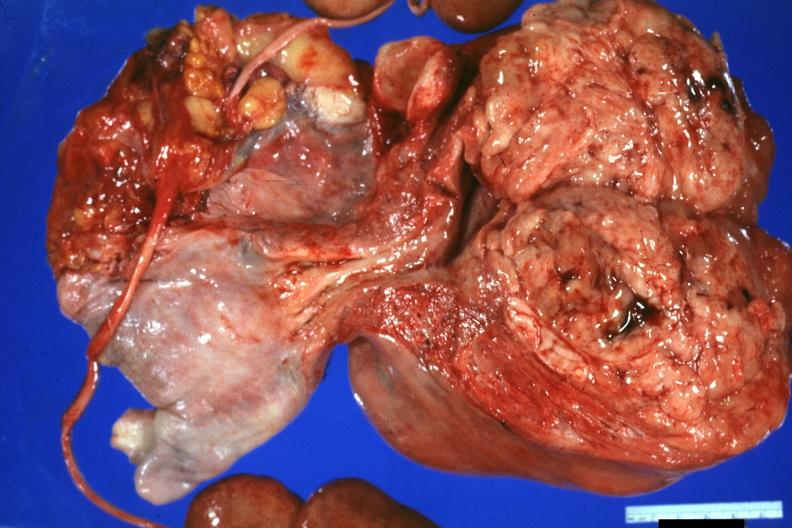s leiomyomas present?
Answer the question using a single word or phrase. No 